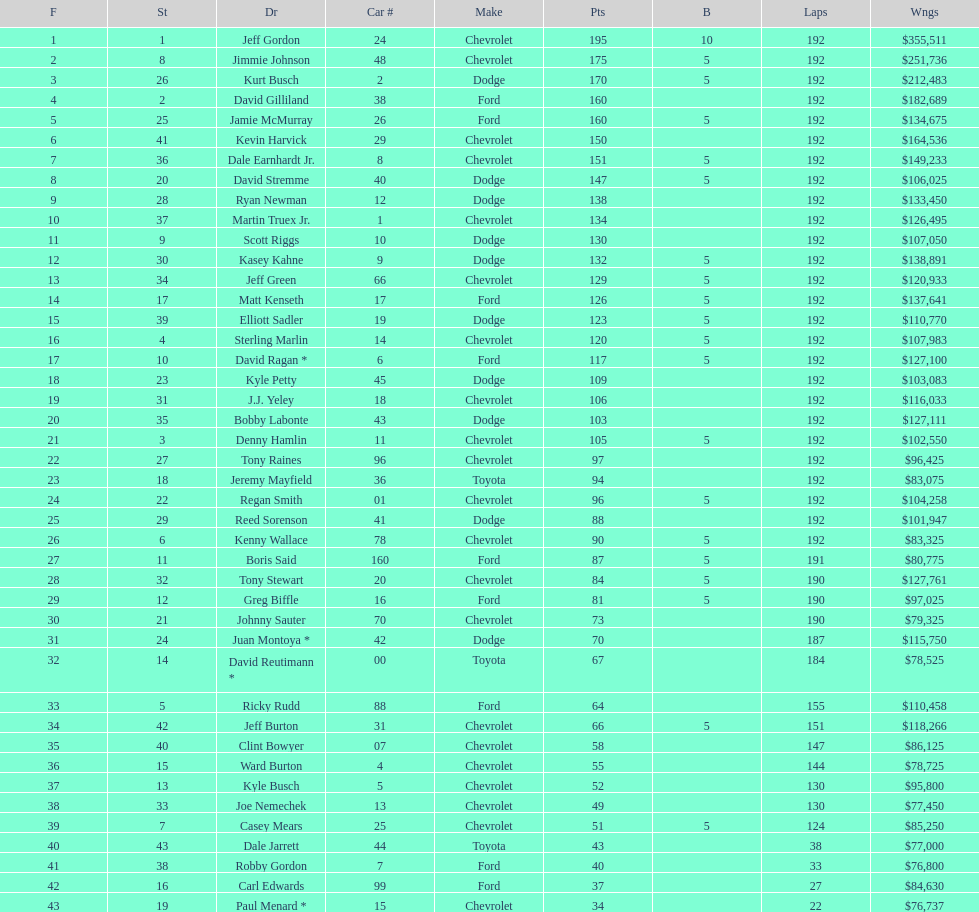What make did kurt busch drive? Dodge. 